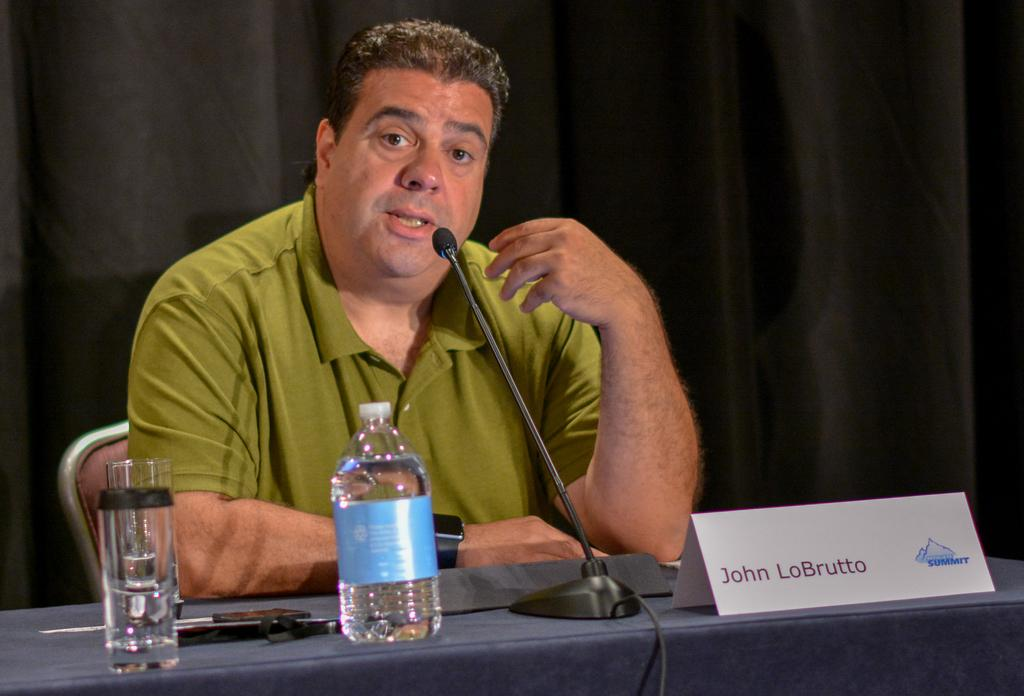Who is the main subject in the image? There is a man in the image. What is the man doing in the image? The man is speaking in the image. What object is in front of the man? There is a microphone in front of the man. Where is the man sitting in the image? The man is sitting at a table in the image. What type of hen can be seen performing on stage in the image? There is no hen present in the image, nor is there a stage or performance depicted. 